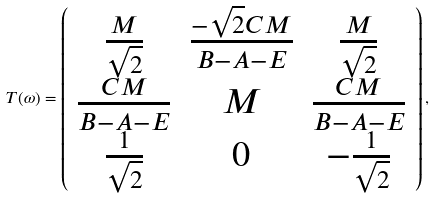<formula> <loc_0><loc_0><loc_500><loc_500>T ( \omega ) = \left ( \begin{array} { c c c } \frac { M } { \sqrt { 2 } } & \frac { - \sqrt { 2 } C M } { B - A - E } & \frac { M } { \sqrt { 2 } } \\ \frac { C M } { B - A - E } & M & \frac { C M } { B - A - E } \\ \frac { 1 } { \sqrt { 2 } } & 0 & - \frac { 1 } { \sqrt { 2 } } \end{array} \right ) ,</formula> 